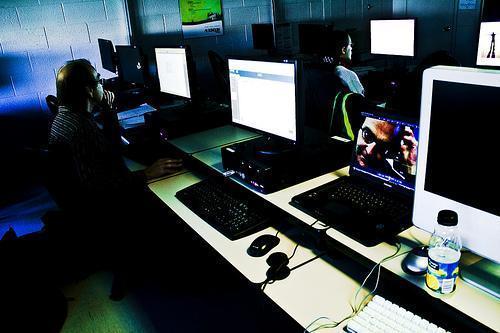How many people are pictured?
Give a very brief answer. 2. 